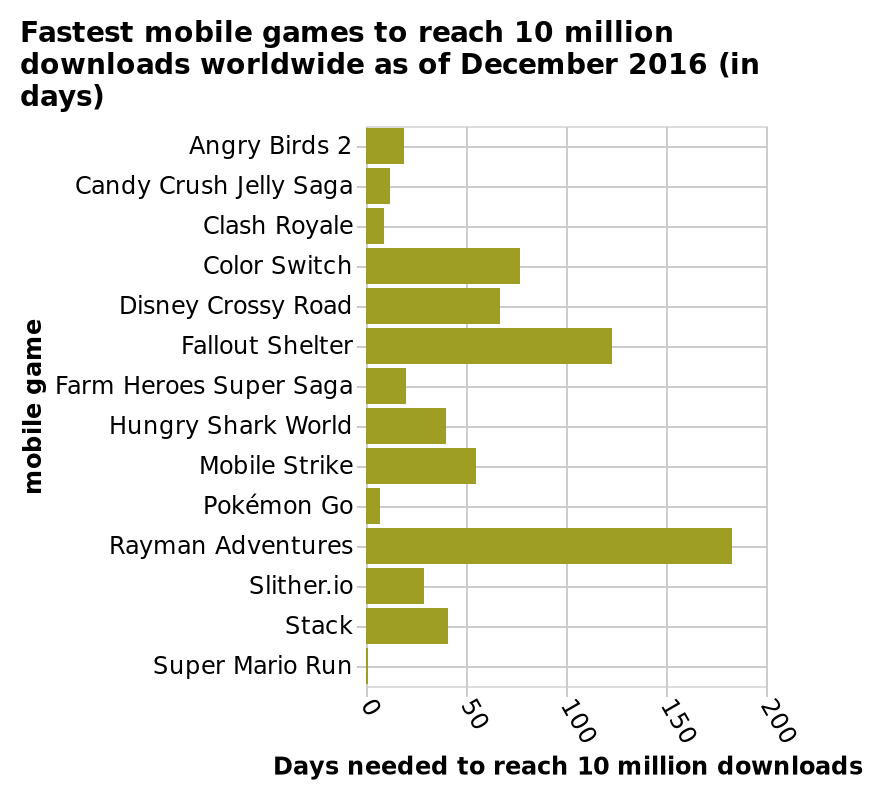<image>
What is the purpose of the bar chart?  The purpose of the bar chart is to measure responses of mobile game download as a categorical scale for reaching 10 million downloads worldwide in 2016. please summary the statistics and relations of the chart The bar chart measures responses of mobile game download as categorical scale to reach 10 million downloads worldwide in 2016. Which mobile game is placed at the lowest position on the y-axis of the bar graph? Super Mario Run What is the range of values on the x-axis of the bar graph? 0 to 200 